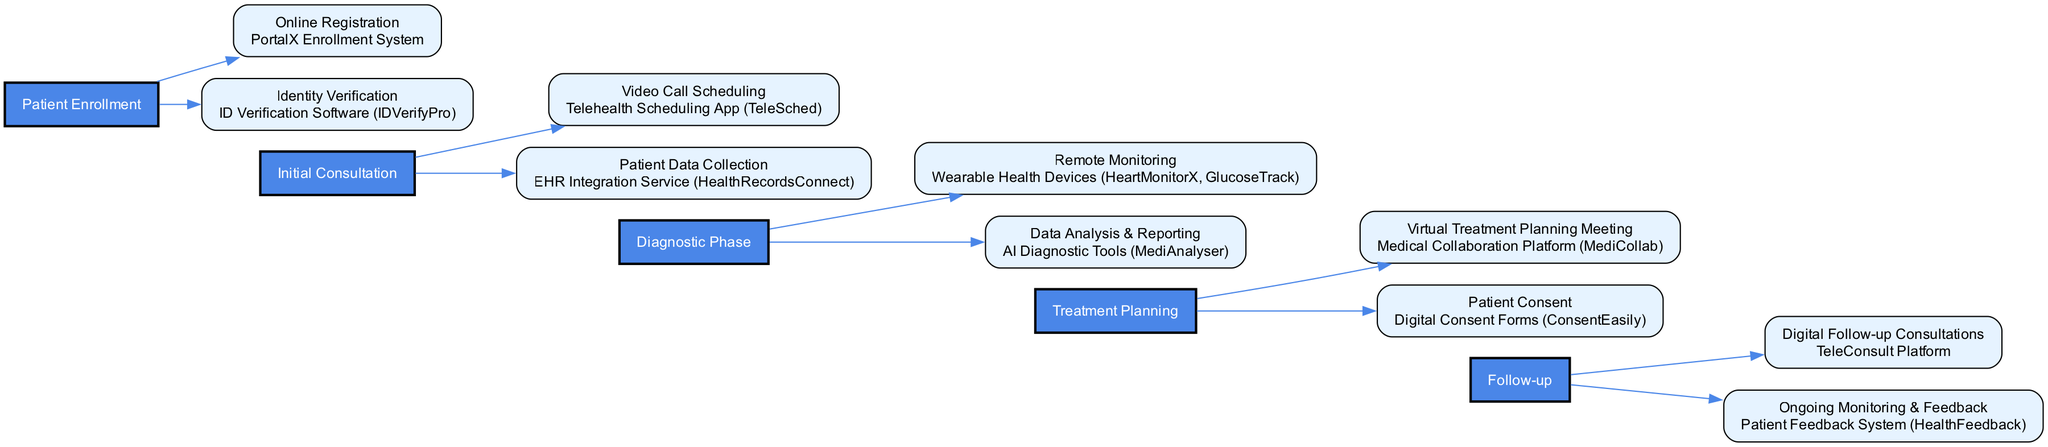What is the first stage in the clinical pathway? The first stage is shown at the beginning of the diagram under "Stage", and it is labeled "Patient Enrollment".
Answer: Patient Enrollment How many actions are listed in the "Follow-up" stage? The "Follow-up" stage has two actions listed underneath it, which are "Digital Follow-up Consultations" and "Ongoing Monitoring & Feedback".
Answer: 2 Which tool is used for "Video Call Scheduling"? The action "Video Call Scheduling" is linked to the tool mentioned next to it in the diagram, which is "Telehealth Scheduling App (TeleSched)".
Answer: Telehealth Scheduling App (TeleSched) What is the last action in the clinical pathway? The last action appears under the last stage "Follow-up", which is labeled "Ongoing Monitoring & Feedback".
Answer: Ongoing Monitoring & Feedback What tool is utilized for "Patient Consent"? The action "Patient Consent" is associated with the tool shown in the same box, which is "Digital Consent Forms (ConsentEasily)".
Answer: Digital Consent Forms (ConsentEasily) How many stages are present in the clinical pathway? By counting the stages outlined in the diagram, there are a total of five stages in the clinical pathway.
Answer: 5 Which stage comes after "Initial Consultation"? The flow of the diagram indicates that the stage following "Initial Consultation" is the "Diagnostic Phase".
Answer: Diagnostic Phase How many tools are mentioned in the "Treatment Planning" stage? The "Treatment Planning" stage lists two actions, each associated with a tool, hence there are two tools mentioned: "Medical Collaboration Platform (MediCollab)" and "Digital Consent Forms (ConsentEasily)".
Answer: 2 What action occurs prior to "Remote Monitoring"? To find the action before "Remote Monitoring", we look at the stages leading up to "Diagnostic Phase"; the preceding stage is "Initial Consultation", where the last action is "Patient Data Collection".
Answer: Patient Data Collection 